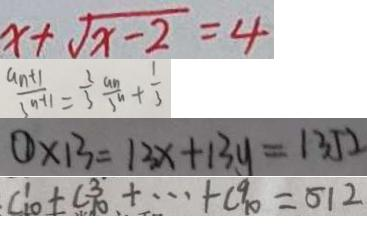<formula> <loc_0><loc_0><loc_500><loc_500>x + \sqrt { x - 2 } = 4 
 \frac { a n + 1 } { 3 n + 1 } = \frac { 2 } { 3 } \frac { a n } { 3 n } + \frac { 1 } { 3 } 
 \textcircled { 1 } \times 1 3 = 1 3 x + 1 3 y = 1 3 5 2 
 C _ { 1 0 } ^ { 1 } + C \frac { 3 } { 1 0 } + \cdots + C _ { 1 0 } ^ { 9 } = 5 1 2</formula> 